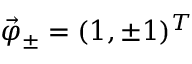Convert formula to latex. <formula><loc_0><loc_0><loc_500><loc_500>\vec { \varphi } _ { \pm } = ( 1 , \pm 1 ) ^ { T }</formula> 